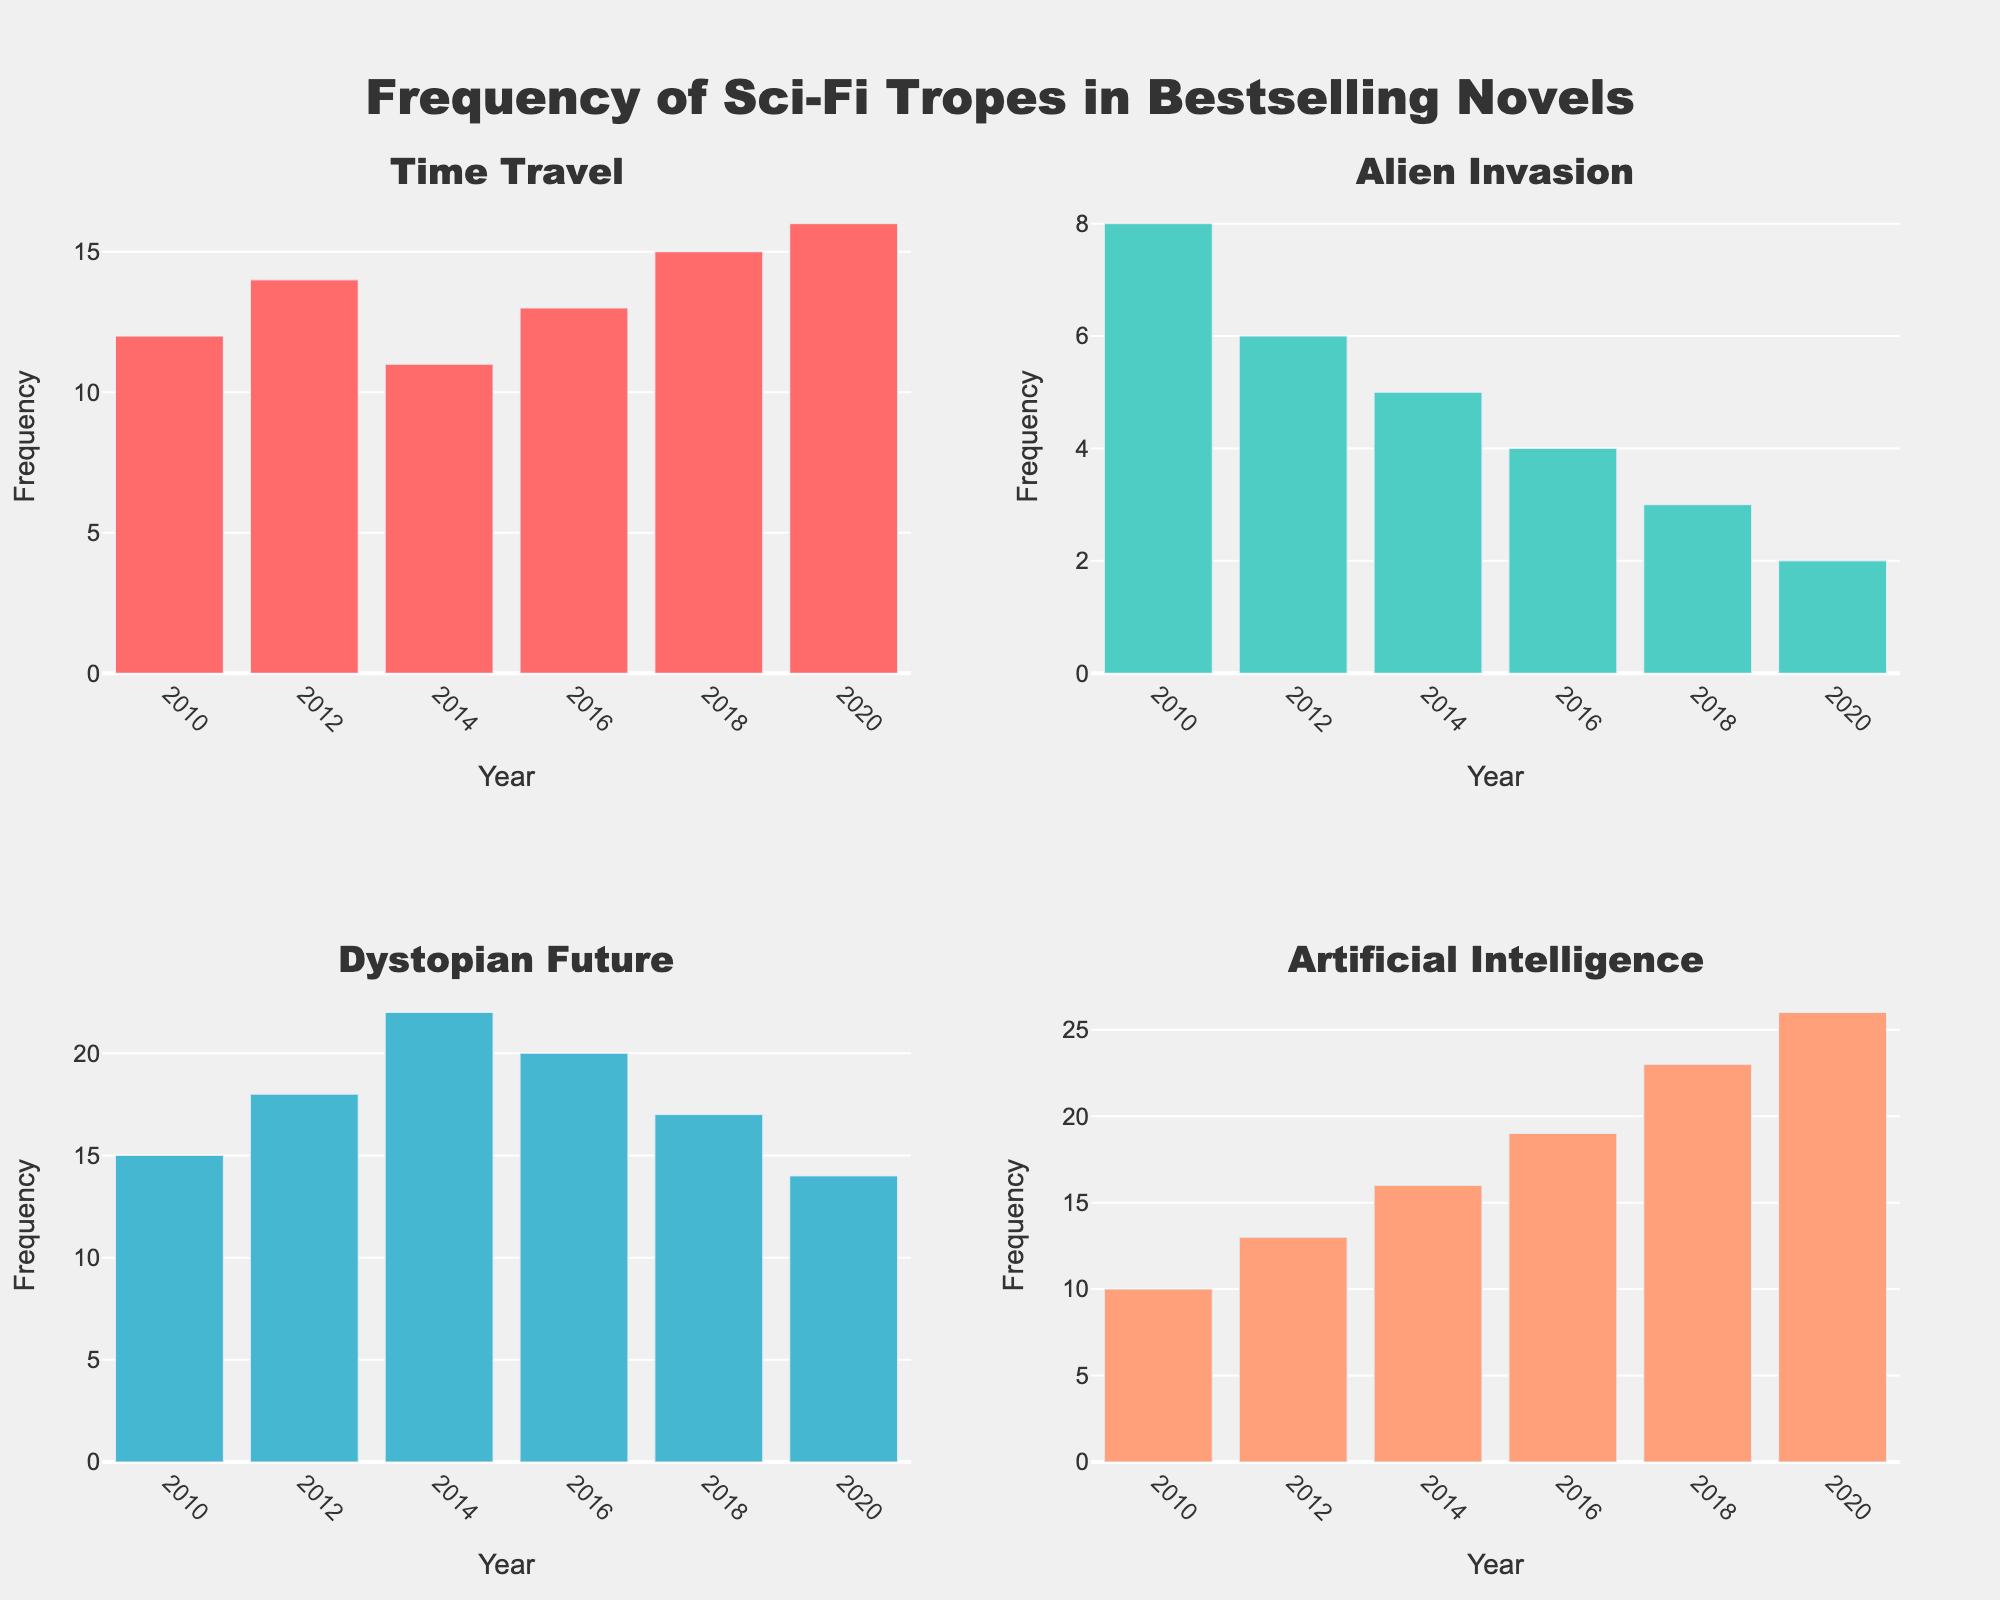What is the frequency of the 'Dystopian Future' trope in 2014? To find the frequency of the 'Dystopian Future' trope in 2014, locate the 'Dystopian Future' subplot and search for the bar corresponding to the year 2014. The height of this bar represents the frequency.
Answer: 22 Which sci-fi trope had the highest frequency in 2020? Compare the heights of the bars for each year 2020 in each subplot. The highest bar will indicate the trope with the highest frequency.
Answer: Artificial Intelligence How did the frequency of 'Alien Invasion' change from 2010 to 2020? Look at the 'Alien Invasion' subplot and note the heights of the bars for the years 2010 and 2020. Compare these values to determine the change.
Answer: Decreased What is the average frequency of 'Time Travel' from 2010 to 2020? For the 'Time Travel' subplot, sum the heights of the bars for the years 2010, 2012, 2014, 2016, 2018, and 2020, then divide by the number of years (6). (12 + 14 + 11 + 13 + 15 + 16) / 6 gives 81 / 6
Answer: 13.5 In which year did the 'Artificial Intelligence' trope see the biggest increase in frequency compared to the previous year? Check the 'Artificial Intelligence' subplot and compare each year's bar height with the preceding year's to find the biggest increase.
Answer: 2018 How does the trend of the 'Dystopian Future' trope compare with 'Time Travel' from 2010 to 2020? In the 'Dystopian Future' subplot, record the bar heights for each year from 2010 to 2020 and compare the direction of the bars' changes with those in the 'Time Travel' subplot for the same years. Both tropes show varying trends, but 'Dystopian Future' generally increases more consistently than 'Time Travel'.
Answer: 'Dystopian Future' generally increases, 'Time Travel' fluctuates What's the difference in frequency of 'Artificial Intelligence' between 2016 and 2020? Subtract the frequency of 'Artificial Intelligence' in 2016 (19) from that in 2020 (26).
Answer: 7 Which trope has the smallest frequency in any year, and which year is it? Check each subplot and identify the smallest bar among all the years. Note the corresponding trope and year. The smallest bar is 'Alien Invasion' in 2020, with a frequency of 2.
Answer: Alien Invasion, 2020 Which year had the most significant number of high-frequency tropes? For each subplot, count how many bars for each year exceed a certain threshold of frequency, then sum these counts for each year. The year with the highest sum indicates the most significant year. 2020 has high frequencies for 'Time Travel' (16), 'Dystopian Future' (14), and 'Artificial Intelligence' (26).
Answer: 2020 